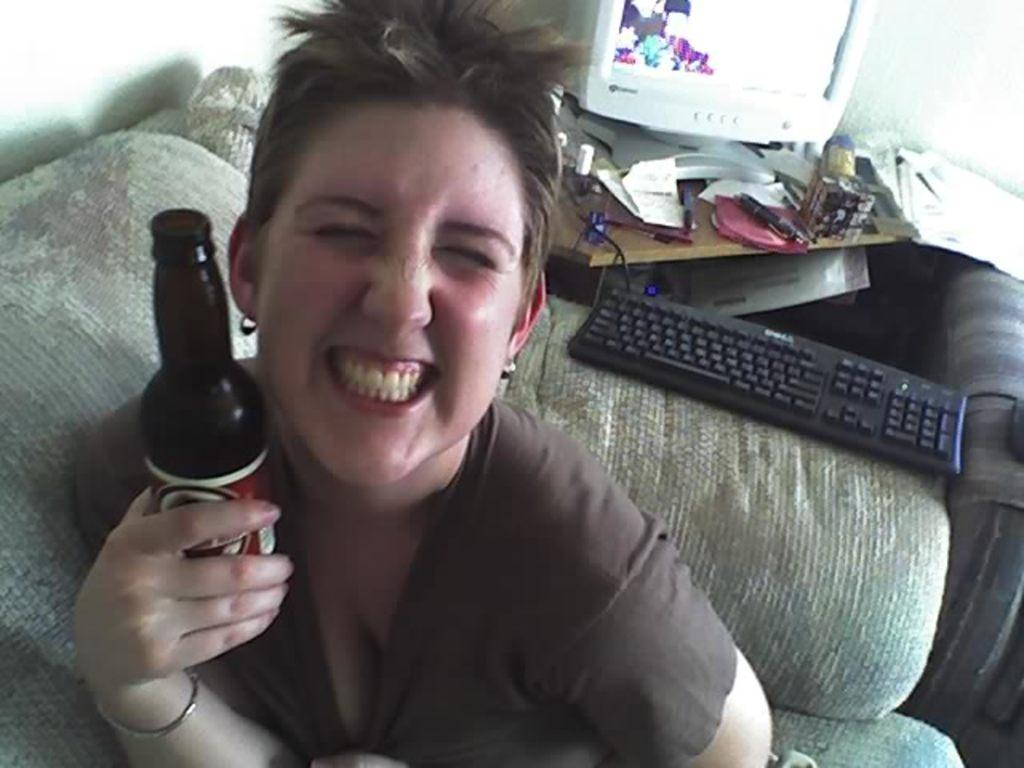Who or what is present in the image? There is a person in the image. What is the person holding in the image? The person is holding a bottle. What can be seen in the background of the image? There is a system visible in the background, and there are objects on a table in the background. What type of bead is being used to create the scene in the image? There is no bead or scene present in the image; it features a person holding a bottle and a background with a system and objects on a table. 